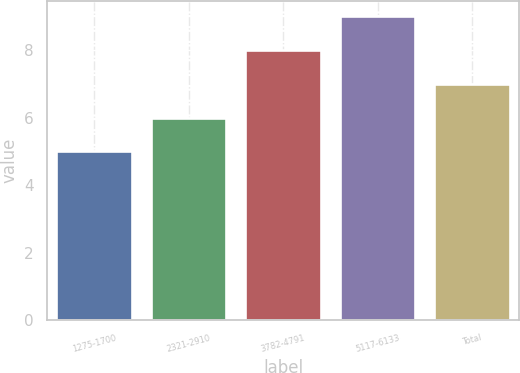Convert chart. <chart><loc_0><loc_0><loc_500><loc_500><bar_chart><fcel>1275-1700<fcel>2321-2910<fcel>3782-4791<fcel>5117-6133<fcel>Total<nl><fcel>5<fcel>6<fcel>8<fcel>9<fcel>7<nl></chart> 